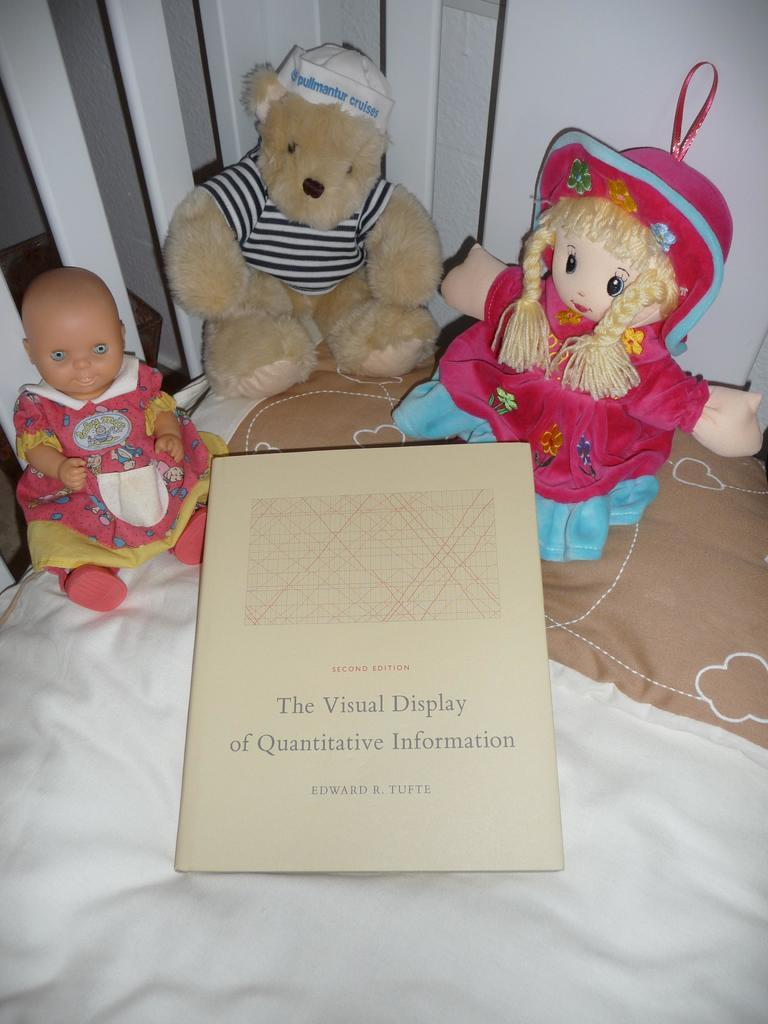What type of furniture is in the image? There is a couch in the image. What is placed on the couch? There are 2 soft toys and a doll on the couch. Can you describe any additional items in the image? There is a paper with writing on it in the image. What type of brass instrument can be seen on the table in the image? There is no brass instrument or table present in the image. How many pigs are visible in the image? There are no pigs present in the image. 